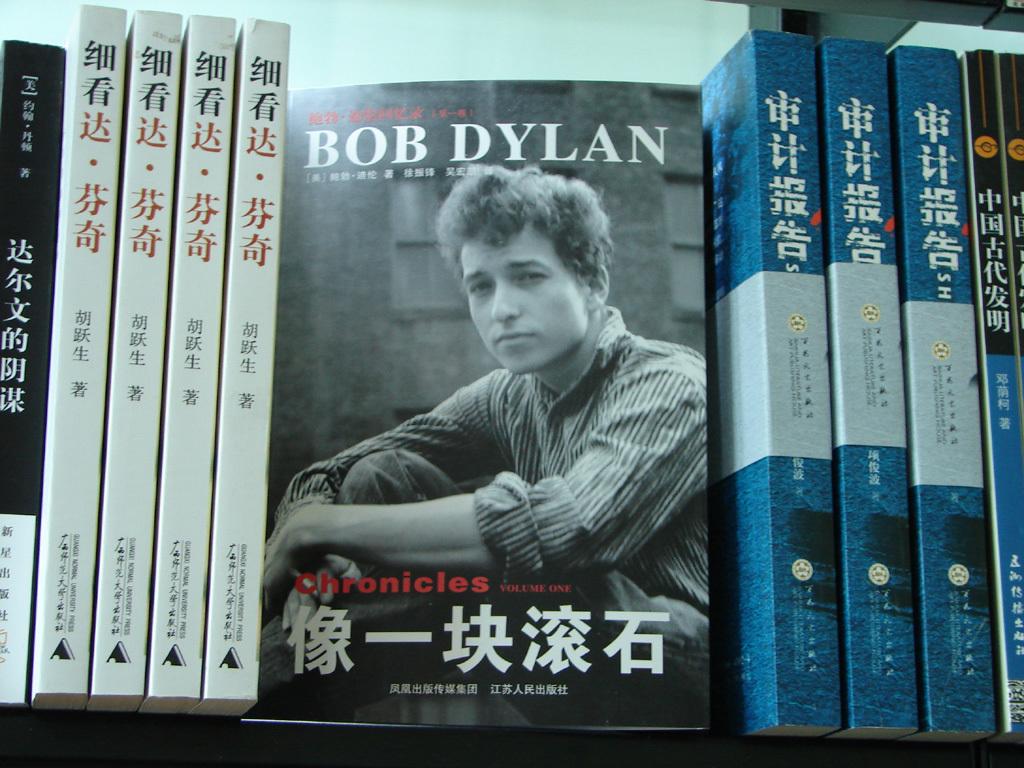Does bob dylan have a book out?
Your answer should be very brief. Yes. 